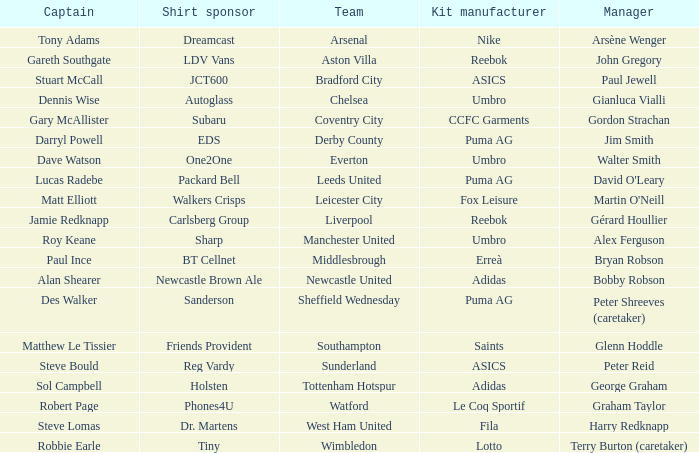Could you parse the entire table as a dict? {'header': ['Captain', 'Shirt sponsor', 'Team', 'Kit manufacturer', 'Manager'], 'rows': [['Tony Adams', 'Dreamcast', 'Arsenal', 'Nike', 'Arsène Wenger'], ['Gareth Southgate', 'LDV Vans', 'Aston Villa', 'Reebok', 'John Gregory'], ['Stuart McCall', 'JCT600', 'Bradford City', 'ASICS', 'Paul Jewell'], ['Dennis Wise', 'Autoglass', 'Chelsea', 'Umbro', 'Gianluca Vialli'], ['Gary McAllister', 'Subaru', 'Coventry City', 'CCFC Garments', 'Gordon Strachan'], ['Darryl Powell', 'EDS', 'Derby County', 'Puma AG', 'Jim Smith'], ['Dave Watson', 'One2One', 'Everton', 'Umbro', 'Walter Smith'], ['Lucas Radebe', 'Packard Bell', 'Leeds United', 'Puma AG', "David O'Leary"], ['Matt Elliott', 'Walkers Crisps', 'Leicester City', 'Fox Leisure', "Martin O'Neill"], ['Jamie Redknapp', 'Carlsberg Group', 'Liverpool', 'Reebok', 'Gérard Houllier'], ['Roy Keane', 'Sharp', 'Manchester United', 'Umbro', 'Alex Ferguson'], ['Paul Ince', 'BT Cellnet', 'Middlesbrough', 'Erreà', 'Bryan Robson'], ['Alan Shearer', 'Newcastle Brown Ale', 'Newcastle United', 'Adidas', 'Bobby Robson'], ['Des Walker', 'Sanderson', 'Sheffield Wednesday', 'Puma AG', 'Peter Shreeves (caretaker)'], ['Matthew Le Tissier', 'Friends Provident', 'Southampton', 'Saints', 'Glenn Hoddle'], ['Steve Bould', 'Reg Vardy', 'Sunderland', 'ASICS', 'Peter Reid'], ['Sol Campbell', 'Holsten', 'Tottenham Hotspur', 'Adidas', 'George Graham'], ['Robert Page', 'Phones4U', 'Watford', 'Le Coq Sportif', 'Graham Taylor'], ['Steve Lomas', 'Dr. Martens', 'West Ham United', 'Fila', 'Harry Redknapp'], ['Robbie Earle', 'Tiny', 'Wimbledon', 'Lotto', 'Terry Burton (caretaker)']]} Which kit maker assists team everton? Umbro. 